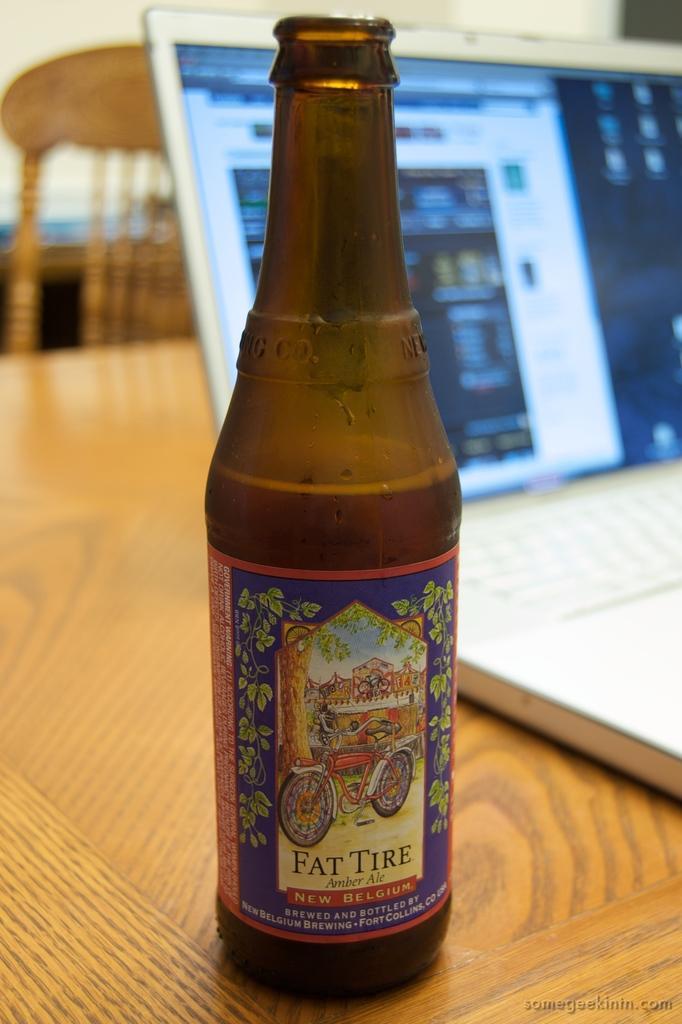In one or two sentences, can you explain what this image depicts? This picture is mainly highlighted with a bottle, laptop on the table. This is a chair. 